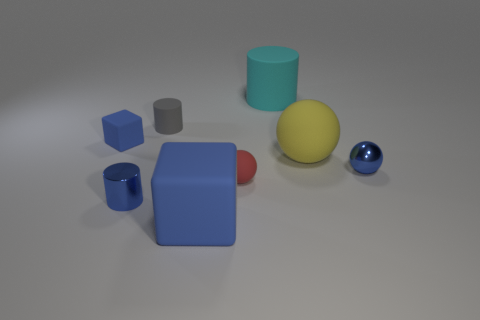Add 1 green shiny cubes. How many objects exist? 9 Subtract all tiny red balls. How many balls are left? 2 Subtract all balls. How many objects are left? 5 Subtract 3 cylinders. How many cylinders are left? 0 Subtract 0 green cylinders. How many objects are left? 8 Subtract all cyan cylinders. Subtract all gray blocks. How many cylinders are left? 2 Subtract all tiny cyan rubber cubes. Subtract all tiny balls. How many objects are left? 6 Add 7 small blue spheres. How many small blue spheres are left? 8 Add 4 metal objects. How many metal objects exist? 6 Subtract all cyan cylinders. How many cylinders are left? 2 